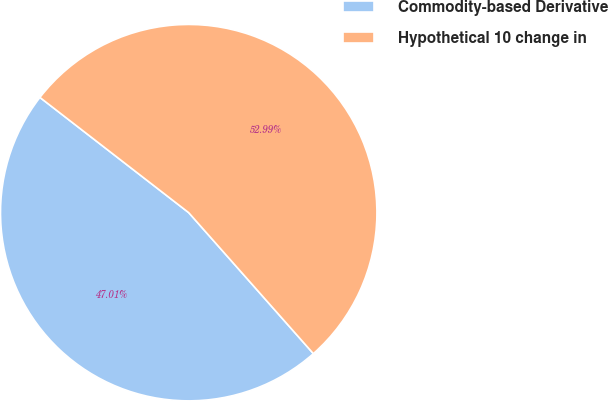<chart> <loc_0><loc_0><loc_500><loc_500><pie_chart><fcel>Commodity-based Derivative<fcel>Hypothetical 10 change in<nl><fcel>47.01%<fcel>52.99%<nl></chart> 